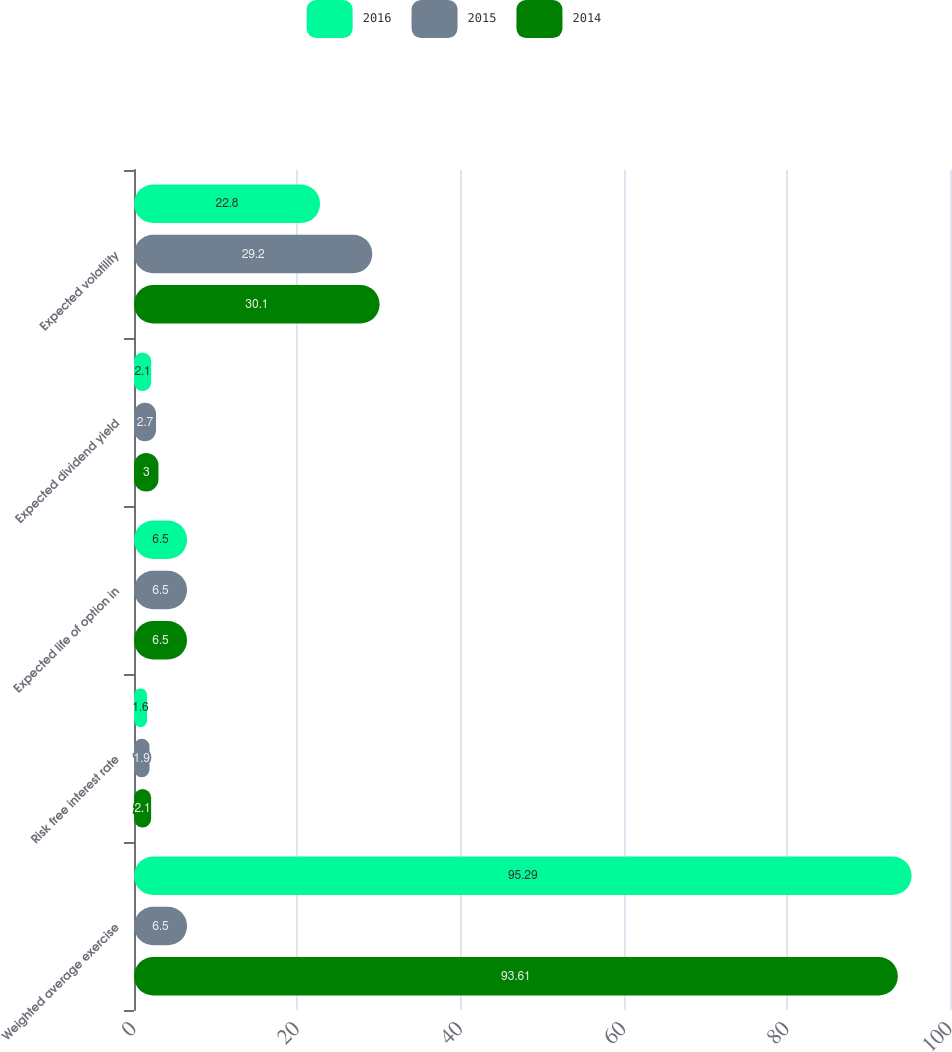<chart> <loc_0><loc_0><loc_500><loc_500><stacked_bar_chart><ecel><fcel>Weighted average exercise<fcel>Risk free interest rate<fcel>Expected life of option in<fcel>Expected dividend yield<fcel>Expected volatility<nl><fcel>2016<fcel>95.29<fcel>1.6<fcel>6.5<fcel>2.1<fcel>22.8<nl><fcel>2015<fcel>6.5<fcel>1.9<fcel>6.5<fcel>2.7<fcel>29.2<nl><fcel>2014<fcel>93.61<fcel>2.1<fcel>6.5<fcel>3<fcel>30.1<nl></chart> 